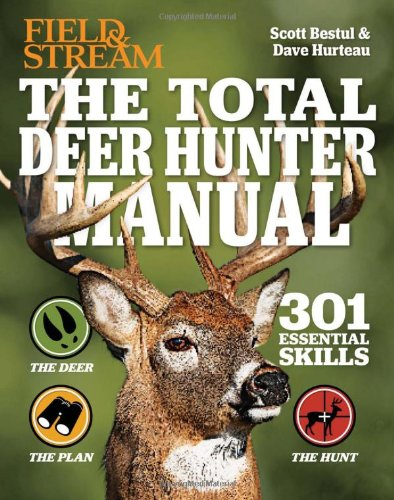Can you explain how this book can be useful for novice deer hunters? This manual is incredibly helpful for beginners as it breaks down 301 essential hunting skills into manageable, step-by-step instructions, ranging from tracking and scouting techniques to selecting the appropriate gear. Does the book provide any insights into deer behavior that might help hunters? Yes, the book includes detailed sections on understanding deer behavior, including movement patterns and habitat preferences, which are crucial for planning successful hunts. 